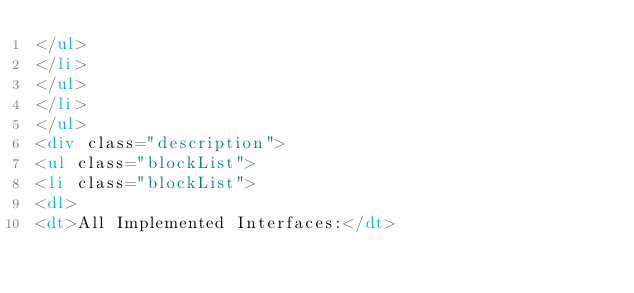<code> <loc_0><loc_0><loc_500><loc_500><_HTML_></ul>
</li>
</ul>
</li>
</ul>
<div class="description">
<ul class="blockList">
<li class="blockList">
<dl>
<dt>All Implemented Interfaces:</dt></code> 